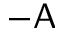<formula> <loc_0><loc_0><loc_500><loc_500>- A</formula> 